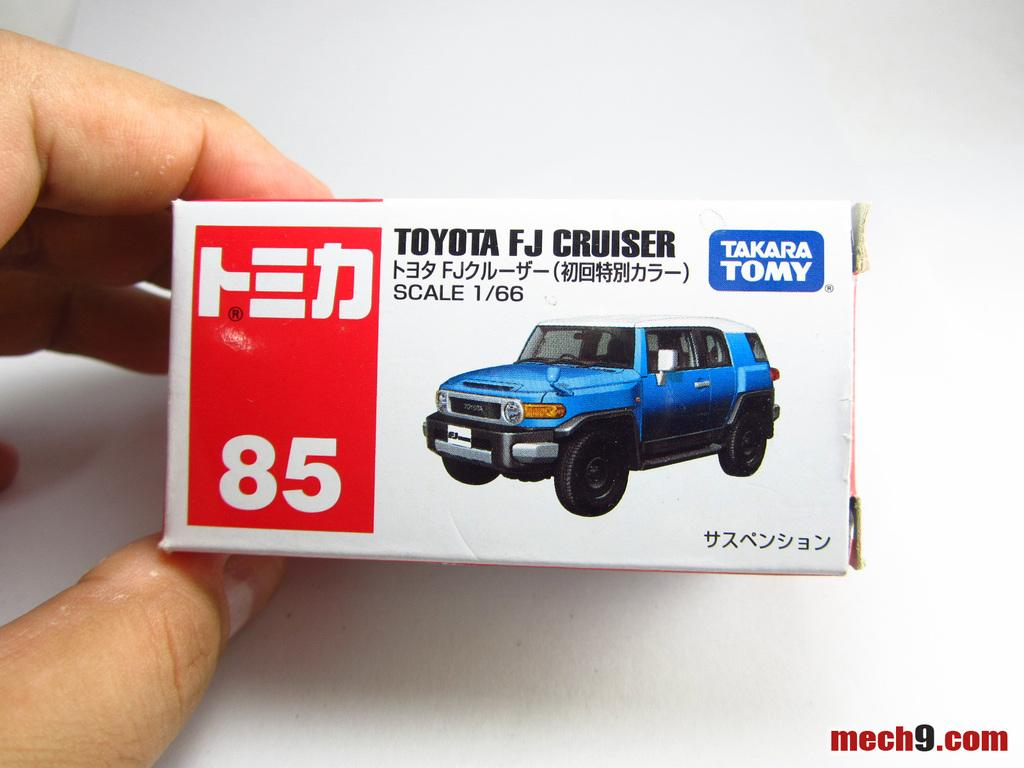What is the person holding in the image? The person is holding a box in the image. Can you describe the person's hand position in the image? The person's fingers are visible on the left side of the image. What is inside the box that the person is holding? There is a vehicle inside the box. What color is the background of the image? The background of the image appears to be white. What type of bun is the person eating in the image? There is no bun present in the image; the person is holding a box with a vehicle inside. Can you see any signs in the image? There are no signs visible in the image. 